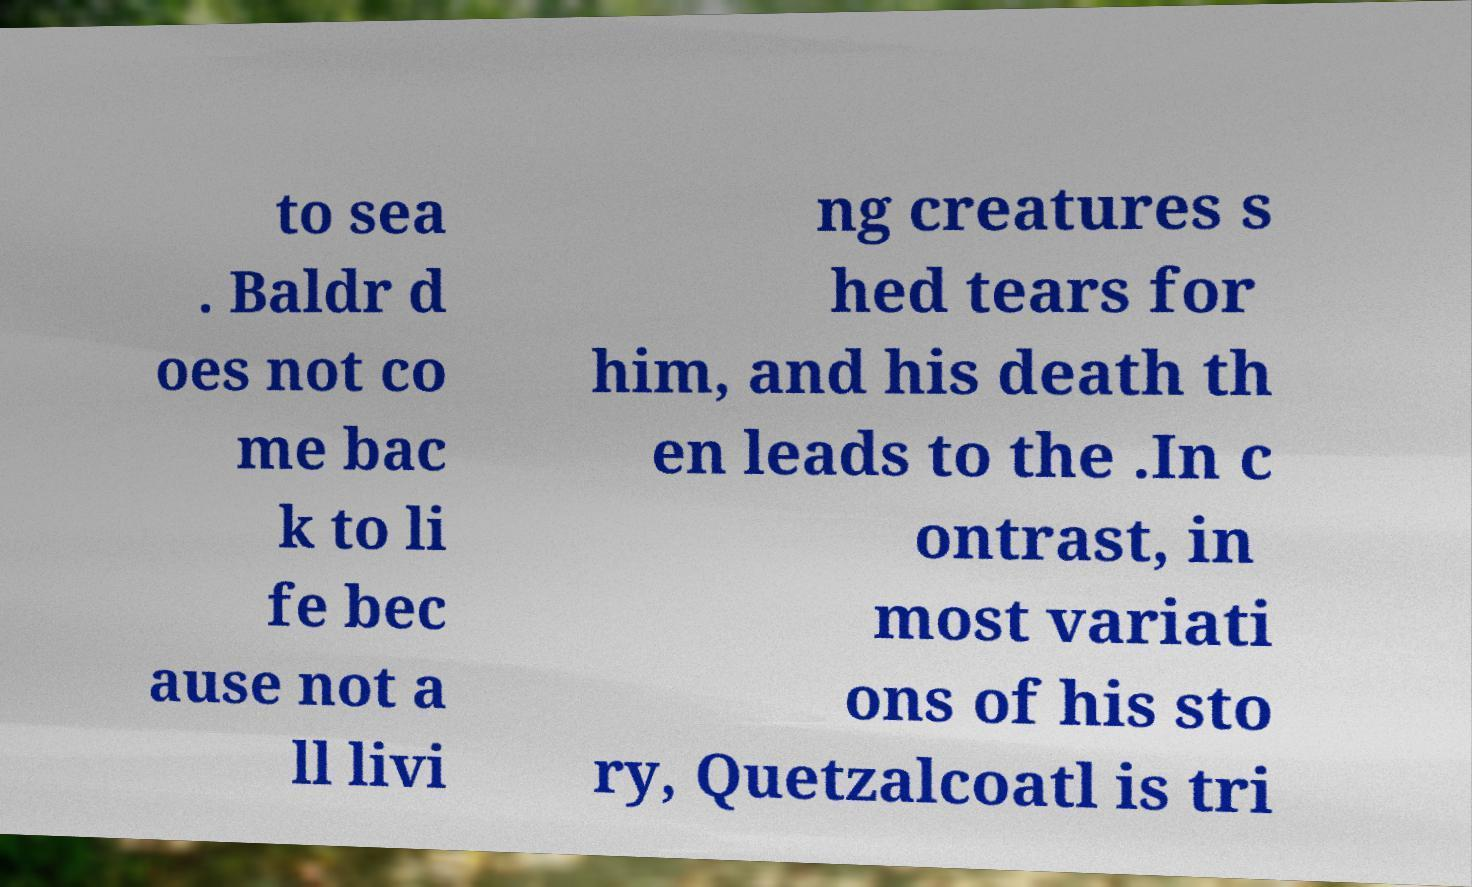What messages or text are displayed in this image? I need them in a readable, typed format. to sea . Baldr d oes not co me bac k to li fe bec ause not a ll livi ng creatures s hed tears for him, and his death th en leads to the .In c ontrast, in most variati ons of his sto ry, Quetzalcoatl is tri 